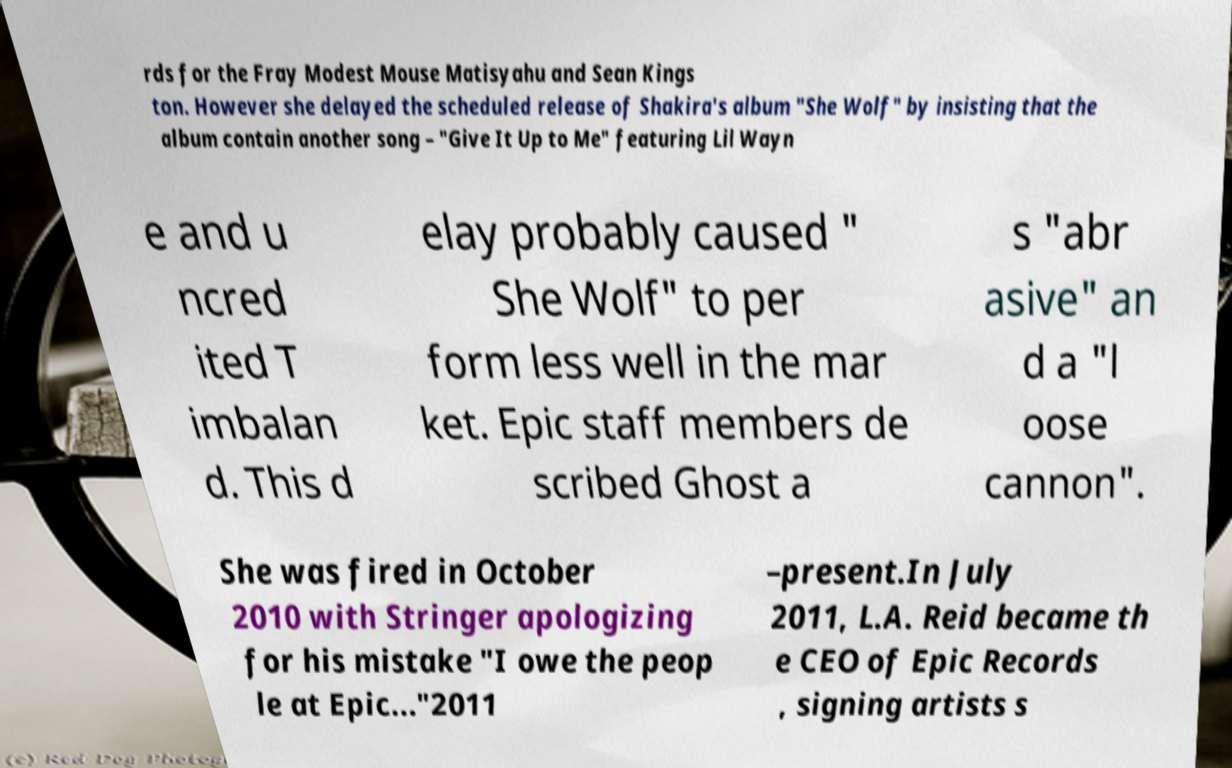For documentation purposes, I need the text within this image transcribed. Could you provide that? rds for the Fray Modest Mouse Matisyahu and Sean Kings ton. However she delayed the scheduled release of Shakira's album "She Wolf" by insisting that the album contain another song – "Give It Up to Me" featuring Lil Wayn e and u ncred ited T imbalan d. This d elay probably caused " She Wolf" to per form less well in the mar ket. Epic staff members de scribed Ghost a s "abr asive" an d a "l oose cannon". She was fired in October 2010 with Stringer apologizing for his mistake "I owe the peop le at Epic..."2011 –present.In July 2011, L.A. Reid became th e CEO of Epic Records , signing artists s 